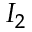Convert formula to latex. <formula><loc_0><loc_0><loc_500><loc_500>I _ { 2 }</formula> 